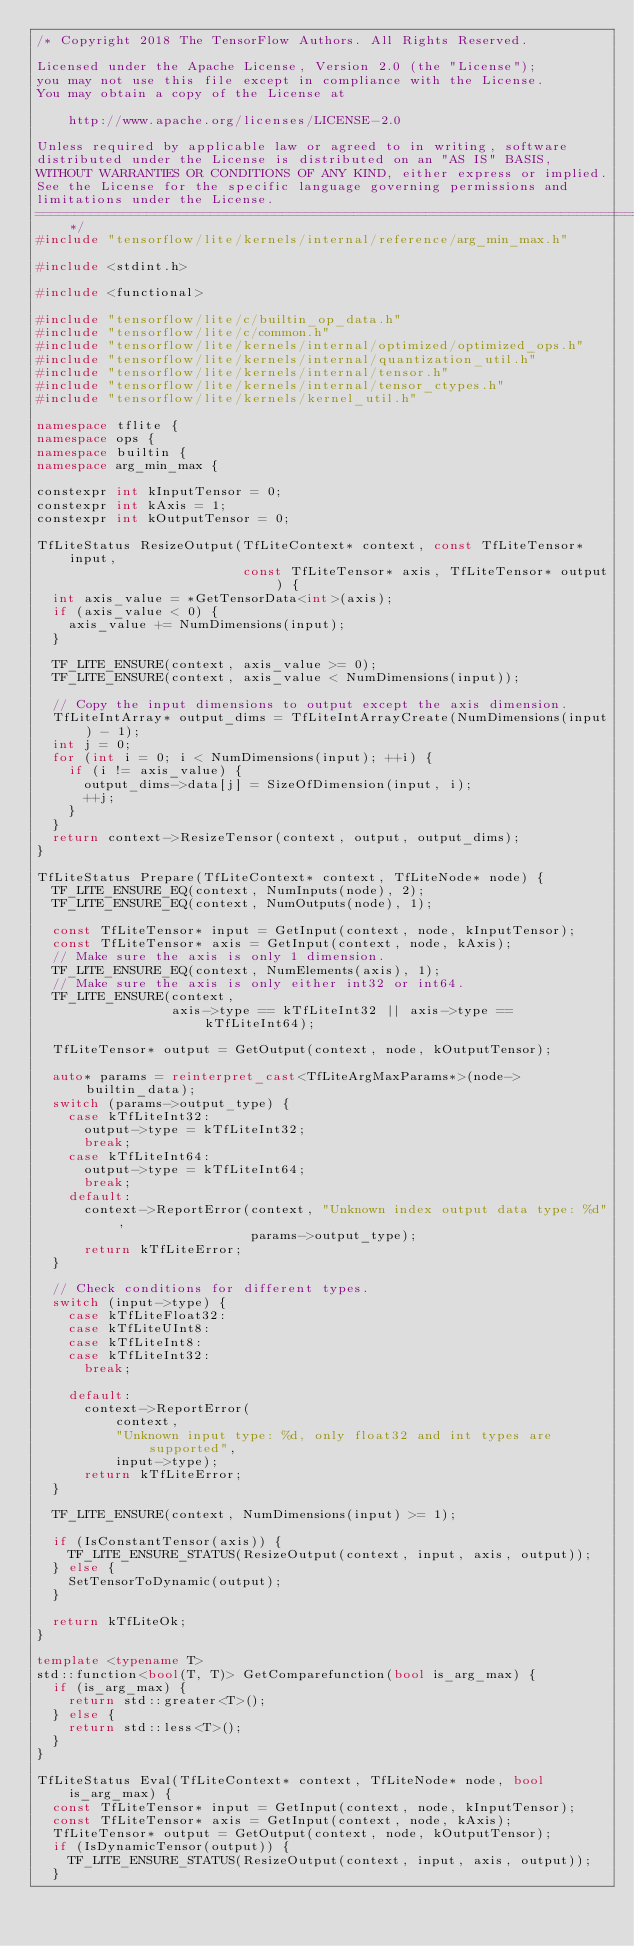<code> <loc_0><loc_0><loc_500><loc_500><_C++_>/* Copyright 2018 The TensorFlow Authors. All Rights Reserved.

Licensed under the Apache License, Version 2.0 (the "License");
you may not use this file except in compliance with the License.
You may obtain a copy of the License at

    http://www.apache.org/licenses/LICENSE-2.0

Unless required by applicable law or agreed to in writing, software
distributed under the License is distributed on an "AS IS" BASIS,
WITHOUT WARRANTIES OR CONDITIONS OF ANY KIND, either express or implied.
See the License for the specific language governing permissions and
limitations under the License.
==============================================================================*/
#include "tensorflow/lite/kernels/internal/reference/arg_min_max.h"

#include <stdint.h>

#include <functional>

#include "tensorflow/lite/c/builtin_op_data.h"
#include "tensorflow/lite/c/common.h"
#include "tensorflow/lite/kernels/internal/optimized/optimized_ops.h"
#include "tensorflow/lite/kernels/internal/quantization_util.h"
#include "tensorflow/lite/kernels/internal/tensor.h"
#include "tensorflow/lite/kernels/internal/tensor_ctypes.h"
#include "tensorflow/lite/kernels/kernel_util.h"

namespace tflite {
namespace ops {
namespace builtin {
namespace arg_min_max {

constexpr int kInputTensor = 0;
constexpr int kAxis = 1;
constexpr int kOutputTensor = 0;

TfLiteStatus ResizeOutput(TfLiteContext* context, const TfLiteTensor* input,
                          const TfLiteTensor* axis, TfLiteTensor* output) {
  int axis_value = *GetTensorData<int>(axis);
  if (axis_value < 0) {
    axis_value += NumDimensions(input);
  }

  TF_LITE_ENSURE(context, axis_value >= 0);
  TF_LITE_ENSURE(context, axis_value < NumDimensions(input));

  // Copy the input dimensions to output except the axis dimension.
  TfLiteIntArray* output_dims = TfLiteIntArrayCreate(NumDimensions(input) - 1);
  int j = 0;
  for (int i = 0; i < NumDimensions(input); ++i) {
    if (i != axis_value) {
      output_dims->data[j] = SizeOfDimension(input, i);
      ++j;
    }
  }
  return context->ResizeTensor(context, output, output_dims);
}

TfLiteStatus Prepare(TfLiteContext* context, TfLiteNode* node) {
  TF_LITE_ENSURE_EQ(context, NumInputs(node), 2);
  TF_LITE_ENSURE_EQ(context, NumOutputs(node), 1);

  const TfLiteTensor* input = GetInput(context, node, kInputTensor);
  const TfLiteTensor* axis = GetInput(context, node, kAxis);
  // Make sure the axis is only 1 dimension.
  TF_LITE_ENSURE_EQ(context, NumElements(axis), 1);
  // Make sure the axis is only either int32 or int64.
  TF_LITE_ENSURE(context,
                 axis->type == kTfLiteInt32 || axis->type == kTfLiteInt64);

  TfLiteTensor* output = GetOutput(context, node, kOutputTensor);

  auto* params = reinterpret_cast<TfLiteArgMaxParams*>(node->builtin_data);
  switch (params->output_type) {
    case kTfLiteInt32:
      output->type = kTfLiteInt32;
      break;
    case kTfLiteInt64:
      output->type = kTfLiteInt64;
      break;
    default:
      context->ReportError(context, "Unknown index output data type: %d",
                           params->output_type);
      return kTfLiteError;
  }

  // Check conditions for different types.
  switch (input->type) {
    case kTfLiteFloat32:
    case kTfLiteUInt8:
    case kTfLiteInt8:
    case kTfLiteInt32:
      break;

    default:
      context->ReportError(
          context,
          "Unknown input type: %d, only float32 and int types are supported",
          input->type);
      return kTfLiteError;
  }

  TF_LITE_ENSURE(context, NumDimensions(input) >= 1);

  if (IsConstantTensor(axis)) {
    TF_LITE_ENSURE_STATUS(ResizeOutput(context, input, axis, output));
  } else {
    SetTensorToDynamic(output);
  }

  return kTfLiteOk;
}

template <typename T>
std::function<bool(T, T)> GetComparefunction(bool is_arg_max) {
  if (is_arg_max) {
    return std::greater<T>();
  } else {
    return std::less<T>();
  }
}

TfLiteStatus Eval(TfLiteContext* context, TfLiteNode* node, bool is_arg_max) {
  const TfLiteTensor* input = GetInput(context, node, kInputTensor);
  const TfLiteTensor* axis = GetInput(context, node, kAxis);
  TfLiteTensor* output = GetOutput(context, node, kOutputTensor);
  if (IsDynamicTensor(output)) {
    TF_LITE_ENSURE_STATUS(ResizeOutput(context, input, axis, output));
  }
</code> 